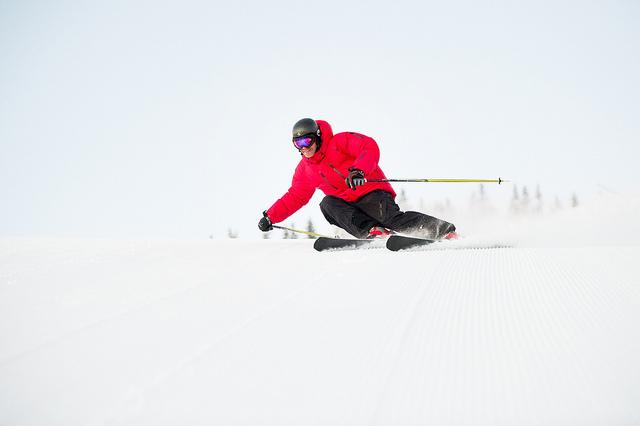What is he doing?
Write a very short answer. Skiing. What color are his pants?
Short answer required. Black. How many trees are in the background?
Be succinct. 15. What color is his jacket?
Keep it brief. Red. 